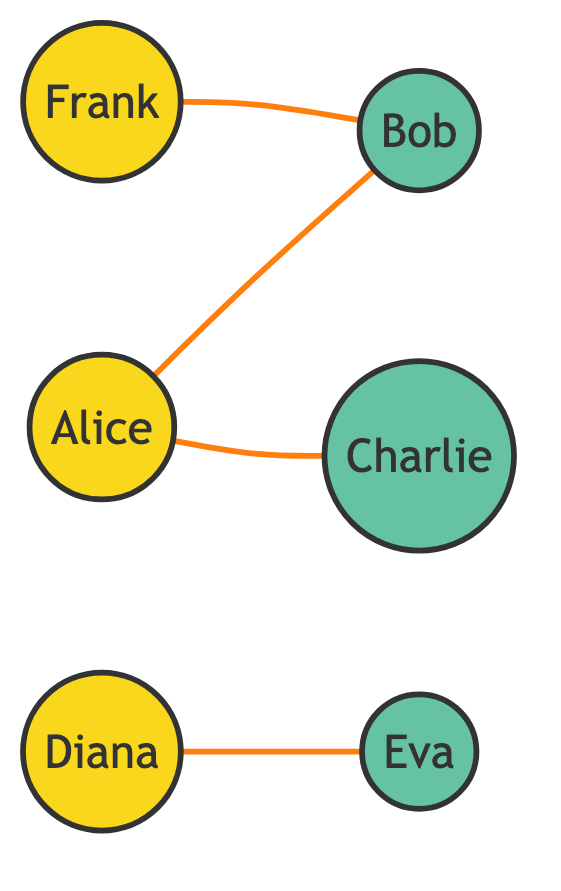What is the total number of nodes in the diagram? The diagram lists six entities connected through edges. Each unique entity (referrer or new customer) counts as one node. Counting them yields Alice, Bob, Charlie, Diana, Eva, and Frank, which totals six nodes.
Answer: 6 Who is the referrer that connects to Bob? By examining the edges that connect nodes, both Alice and Frank have edges leading to Bob. However, if the question is specifically for one individual, it can be stated that Alice is the first listed referrer connected to Bob.
Answer: Alice How many new customers are referred by Alice? The edges connected to Alice indicate that she refers two new customers: Bob and Charlie. Thus, counting these reveals Alice refers a total of two new customers.
Answer: 2 Which referrer has a direct connection to Eva? Looking at the edges, the connection shows that Diana is the only referrer directly linked to Eva, as per the data on the edges. Thus, the answer is Diana.
Answer: Diana What is the total number of edges in the diagram? The edges specify connections between nodes. There are four distinct edges: one from Alice to Bob, one from Alice to Charlie, one from Diana to Eva, and one from Frank to Bob. Counting these gives a total of four edges.
Answer: 4 How many new customers are connected to the referrer Frank? Referring to the edges, Frank is linked directly only to Bob. Therefore, the number of new customers that Frank is connected to is one.
Answer: 1 Which new customer is referred by both Alice and Frank? Analyzing the connections, Bob is the only new customer that is connected through edges from both Alice and Frank. Thus, the answer is Bob.
Answer: Bob How many edges connect to the referrer Diana? Reviewing the connections, Diana has one edge connecting her to Eva, indicating that she is only connected to one new customer. Therefore, there is one edge for Diana.
Answer: 1 